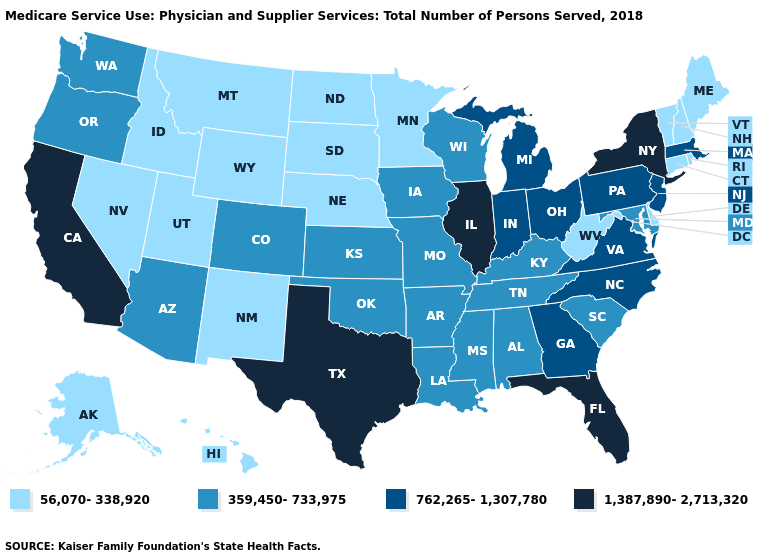What is the highest value in states that border Wisconsin?
Quick response, please. 1,387,890-2,713,320. How many symbols are there in the legend?
Concise answer only. 4. Among the states that border Michigan , does Wisconsin have the lowest value?
Quick response, please. Yes. What is the lowest value in the USA?
Quick response, please. 56,070-338,920. Name the states that have a value in the range 359,450-733,975?
Quick response, please. Alabama, Arizona, Arkansas, Colorado, Iowa, Kansas, Kentucky, Louisiana, Maryland, Mississippi, Missouri, Oklahoma, Oregon, South Carolina, Tennessee, Washington, Wisconsin. What is the highest value in the MidWest ?
Give a very brief answer. 1,387,890-2,713,320. Does the map have missing data?
Give a very brief answer. No. Name the states that have a value in the range 359,450-733,975?
Keep it brief. Alabama, Arizona, Arkansas, Colorado, Iowa, Kansas, Kentucky, Louisiana, Maryland, Mississippi, Missouri, Oklahoma, Oregon, South Carolina, Tennessee, Washington, Wisconsin. How many symbols are there in the legend?
Answer briefly. 4. Which states have the highest value in the USA?
Be succinct. California, Florida, Illinois, New York, Texas. What is the value of Colorado?
Quick response, please. 359,450-733,975. What is the highest value in states that border Virginia?
Write a very short answer. 762,265-1,307,780. Which states have the highest value in the USA?
Concise answer only. California, Florida, Illinois, New York, Texas. What is the value of California?
Concise answer only. 1,387,890-2,713,320. What is the value of New Hampshire?
Short answer required. 56,070-338,920. 